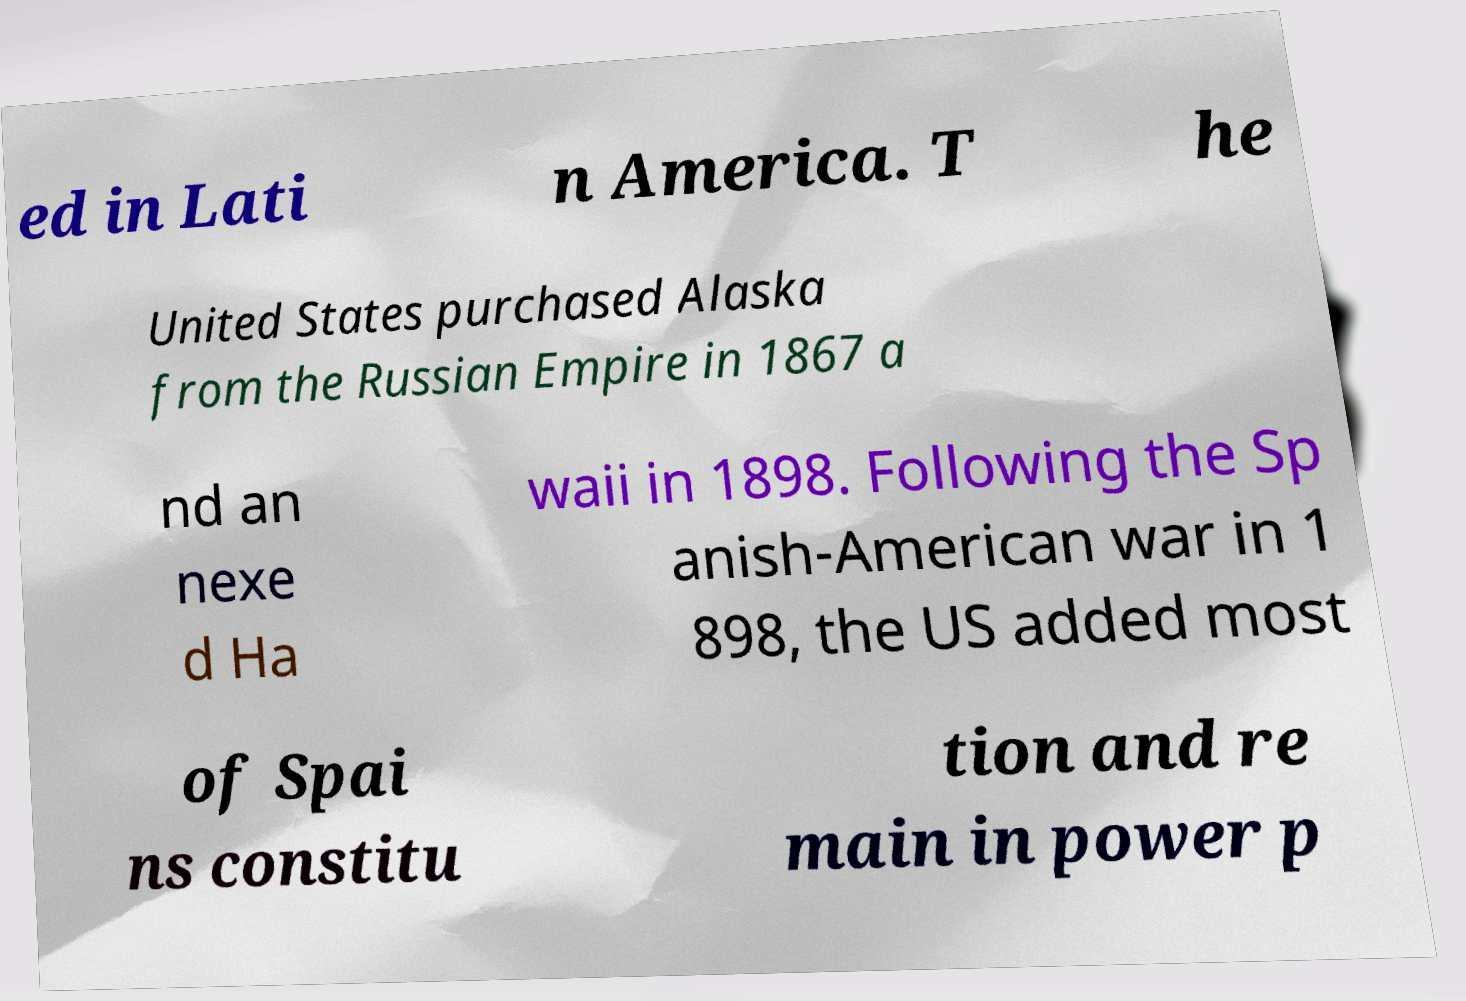What messages or text are displayed in this image? I need them in a readable, typed format. ed in Lati n America. T he United States purchased Alaska from the Russian Empire in 1867 a nd an nexe d Ha waii in 1898. Following the Sp anish-American war in 1 898, the US added most of Spai ns constitu tion and re main in power p 